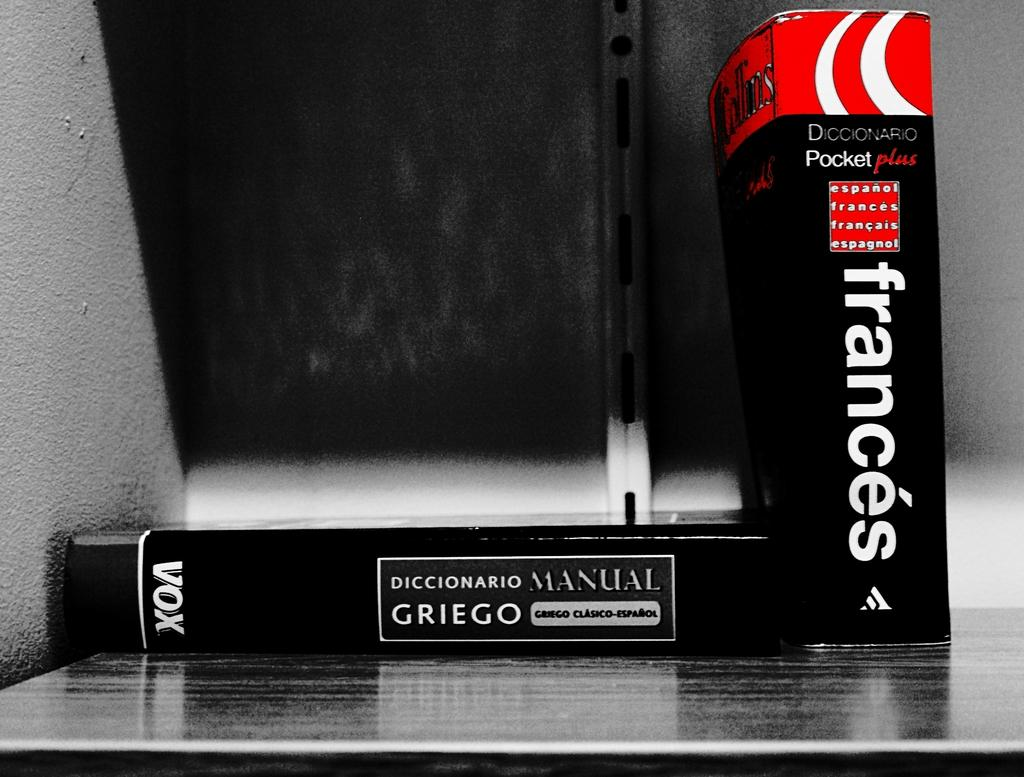<image>
Offer a succinct explanation of the picture presented. a book with the name Frances put on the front 